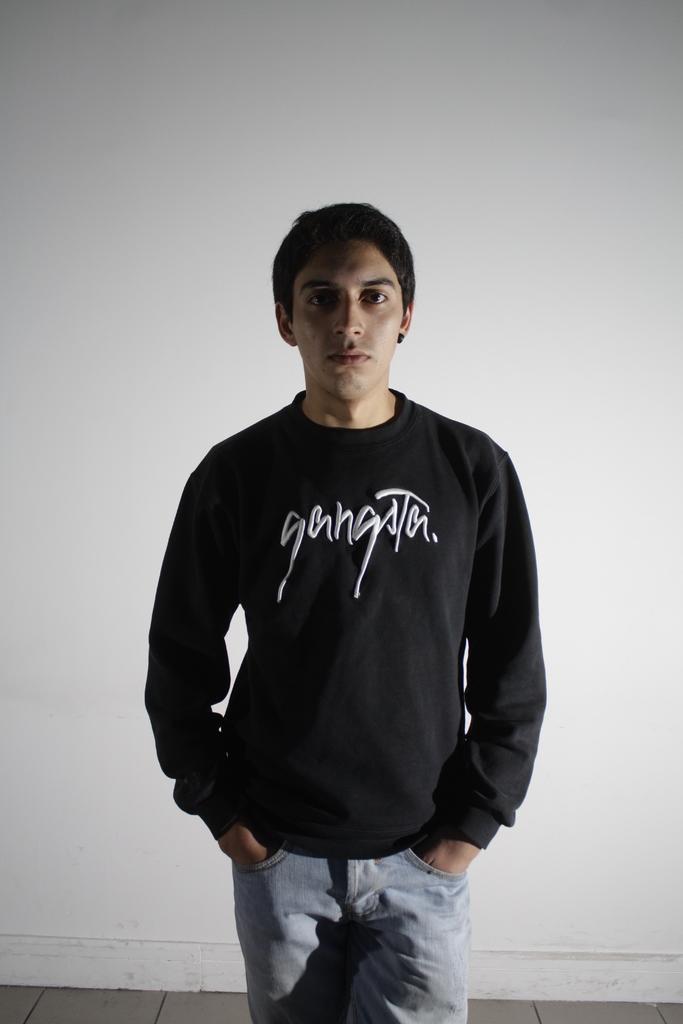How would you summarize this image in a sentence or two? In the picture we can see a man standing with long black color T-shirt and name on it as a gangster and behind him we can see a wall which is white in color. 